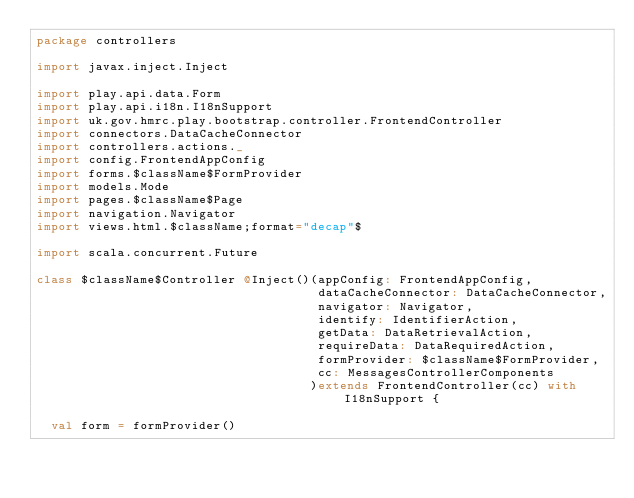Convert code to text. <code><loc_0><loc_0><loc_500><loc_500><_Scala_>package controllers

import javax.inject.Inject

import play.api.data.Form
import play.api.i18n.I18nSupport
import uk.gov.hmrc.play.bootstrap.controller.FrontendController
import connectors.DataCacheConnector
import controllers.actions._
import config.FrontendAppConfig
import forms.$className$FormProvider
import models.Mode
import pages.$className$Page
import navigation.Navigator
import views.html.$className;format="decap"$

import scala.concurrent.Future

class $className$Controller @Inject()(appConfig: FrontendAppConfig,
                                      dataCacheConnector: DataCacheConnector,
                                      navigator: Navigator,
                                      identify: IdentifierAction,
                                      getData: DataRetrievalAction,
                                      requireData: DataRequiredAction,
                                      formProvider: $className$FormProvider,
                                      cc: MessagesControllerComponents
                                     )extends FrontendController(cc) with I18nSupport {

  val form = formProvider()
</code> 